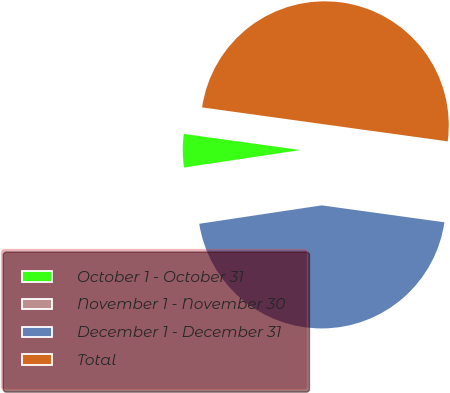Convert chart to OTSL. <chart><loc_0><loc_0><loc_500><loc_500><pie_chart><fcel>October 1 - October 31<fcel>November 1 - November 30<fcel>December 1 - December 31<fcel>Total<nl><fcel>4.56%<fcel>0.01%<fcel>45.44%<fcel>49.99%<nl></chart> 